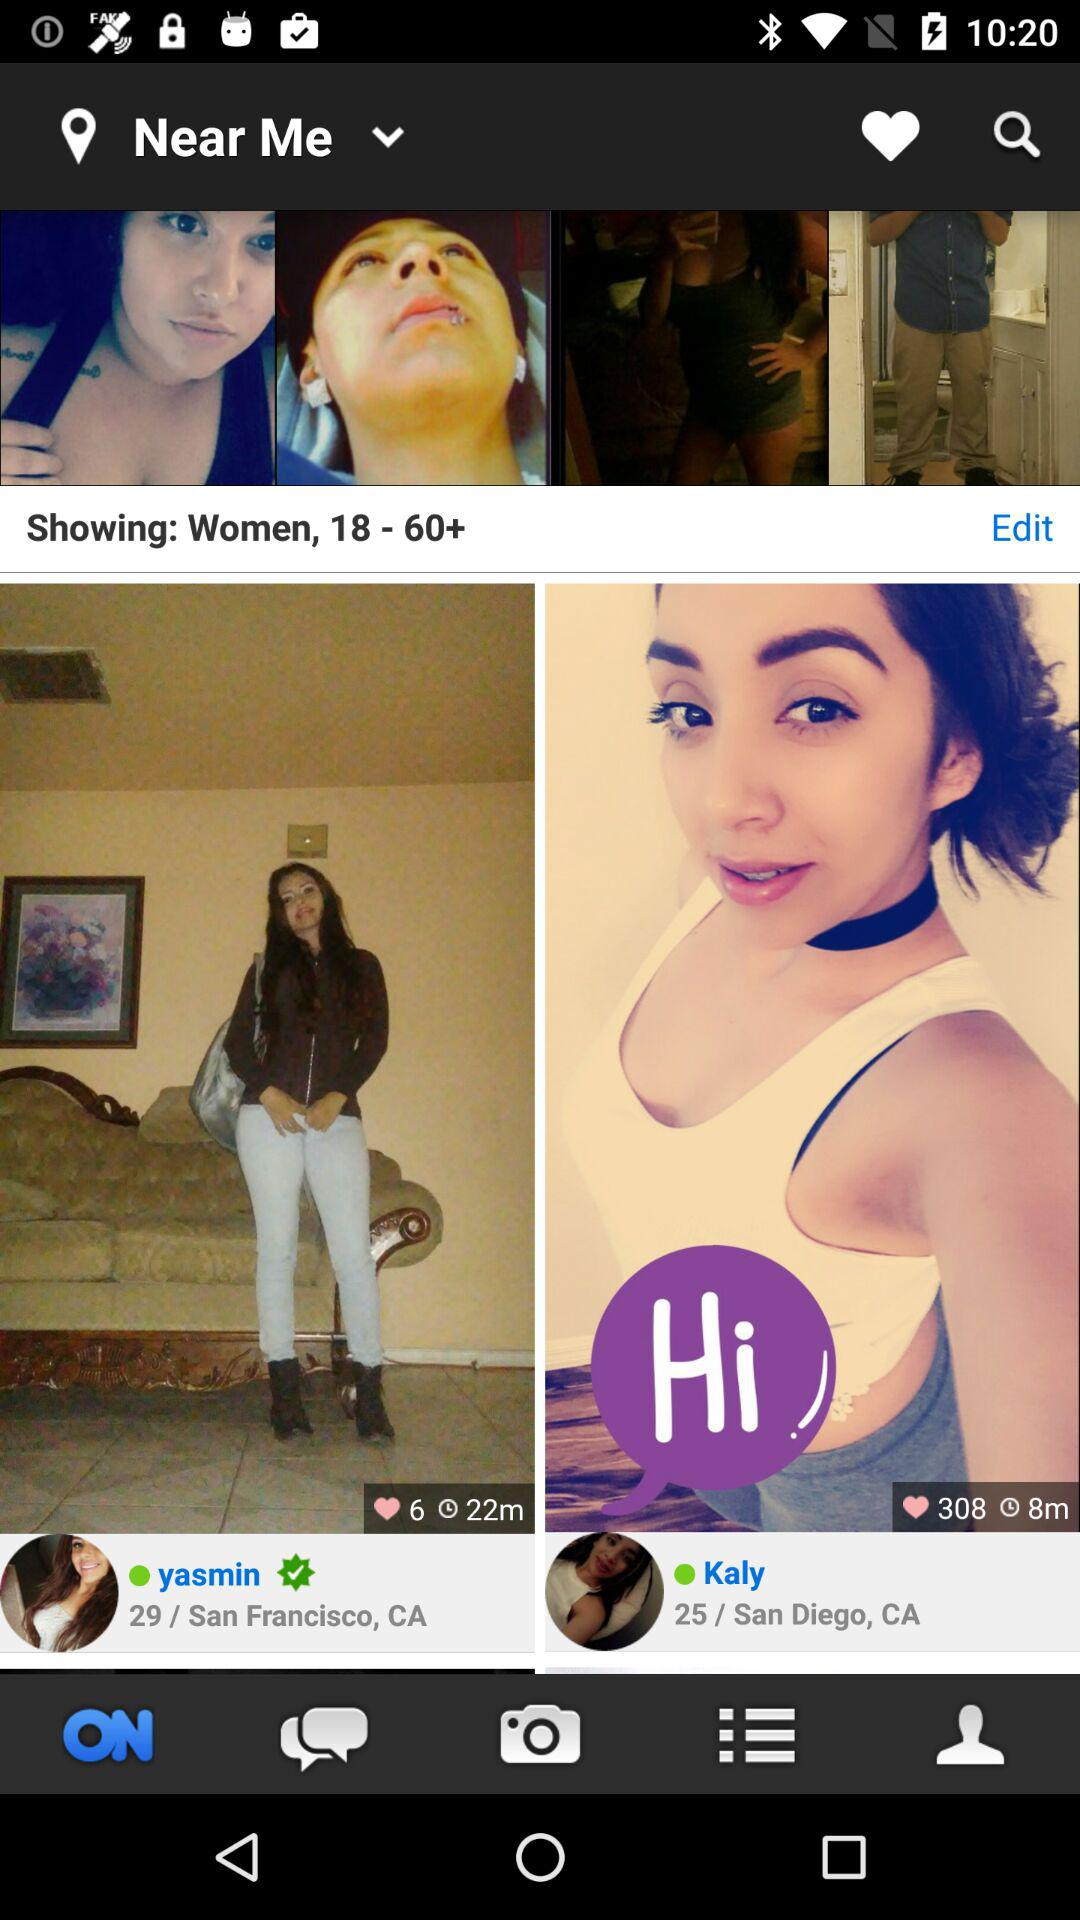What is the location of Kaly? The location is San Diego, CA. 